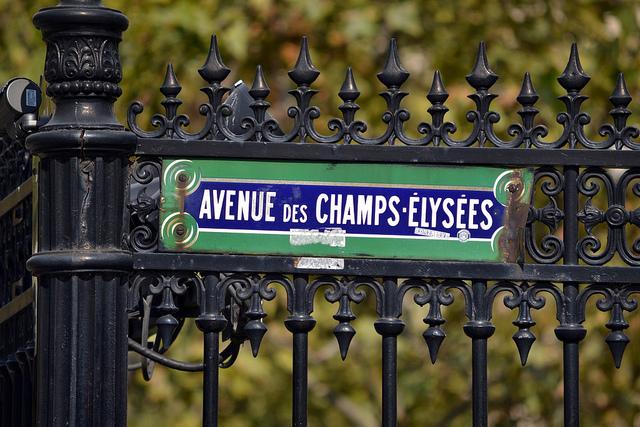What color is the fence?
Give a very brief answer. Black. Is this a French city?
Give a very brief answer. Yes. What street is this?
Answer briefly. Avenue des champs-elysees. 